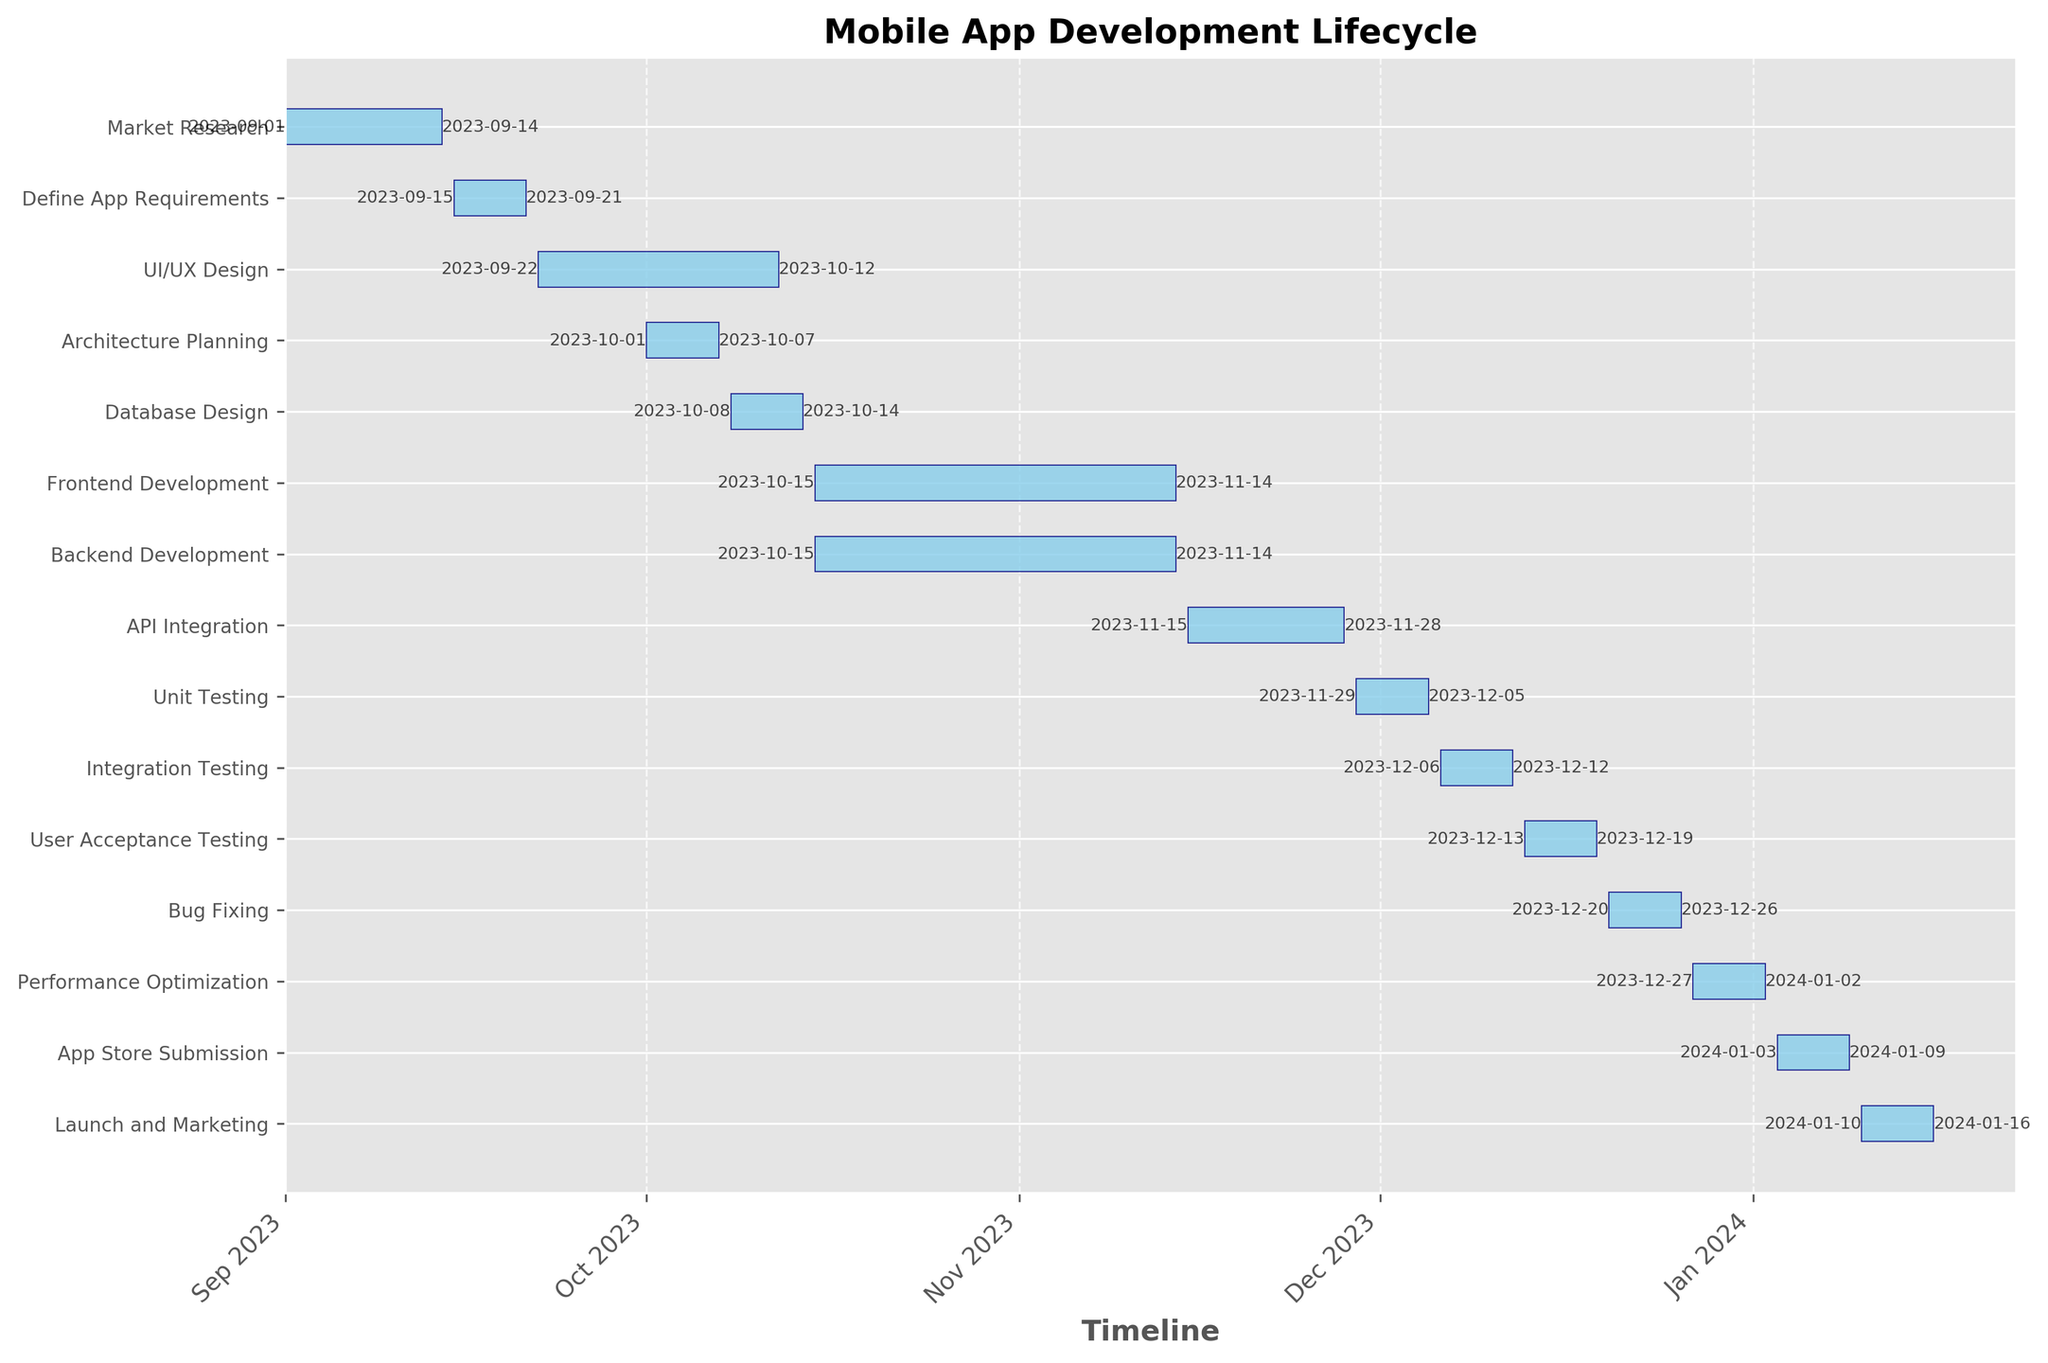What is the duration of the Market Research task? The duration of each task is listed in the dataset. For Market Research, it's 14 days.
Answer: 14 days Which task starts immediately after the Market Research task? Market Research ends on 2023-09-14, and the next task, Define App Requirements, begins on 2023-09-15.
Answer: Define App Requirements How long do the Frontend Development and Backend Development tasks overlap? Both tasks start on 2023-10-15 and end on 2023-11-14. Hence, they overlap completely for 31 days.
Answer: 31 days Which tasks are performed concurrently with the API Integration task? API Integration occurs from 2023-11-15 to 2023-11-28. No tasks are listed as concurrent because both Frontend and Backend Development finish on 2023-11-14, and Unit Testing starts on 2023-11-29.
Answer: None What is the shortest task in the entire development cycle? By comparing the duration of all tasks, the shortest ones have a duration of 7 days. Examples include Define App Requirements, Architecture Planning, Database Design, and several others.
Answer: Define App Requirements (and others of the same duration) What is the total duration from the start of Market Research to the end of the Launch and Marketing phase? Market Research starts on 2023-09-01, and Launch and Marketing ends on 2024-01-16. The total duration is from 2023-09-01 to 2024-01-16, which spans 138 days.
Answer: 138 days During which phase is the UI/UX Design process overlapped by the Architecture Planning task? UI/UX Design runs from 2023-09-22 to 2023-10-12, while Architecture Planning is from 2023-10-01 to 2023-10-07. Hence, the overlap is from 2023-10-01 to 2023-10-07, amounting to 7 days.
Answer: 7 days Which task has the earliest end date? Among all the tasks, Market Research ends the earliest on 2023-09-14.
Answer: Market Research How many tasks begin in October 2023? Tasks starting in October 2023 include UI/UX Design, Architecture Planning, Database Design, Frontend Development, and Backend Development. Counting these gives 5 tasks.
Answer: 5 tasks 